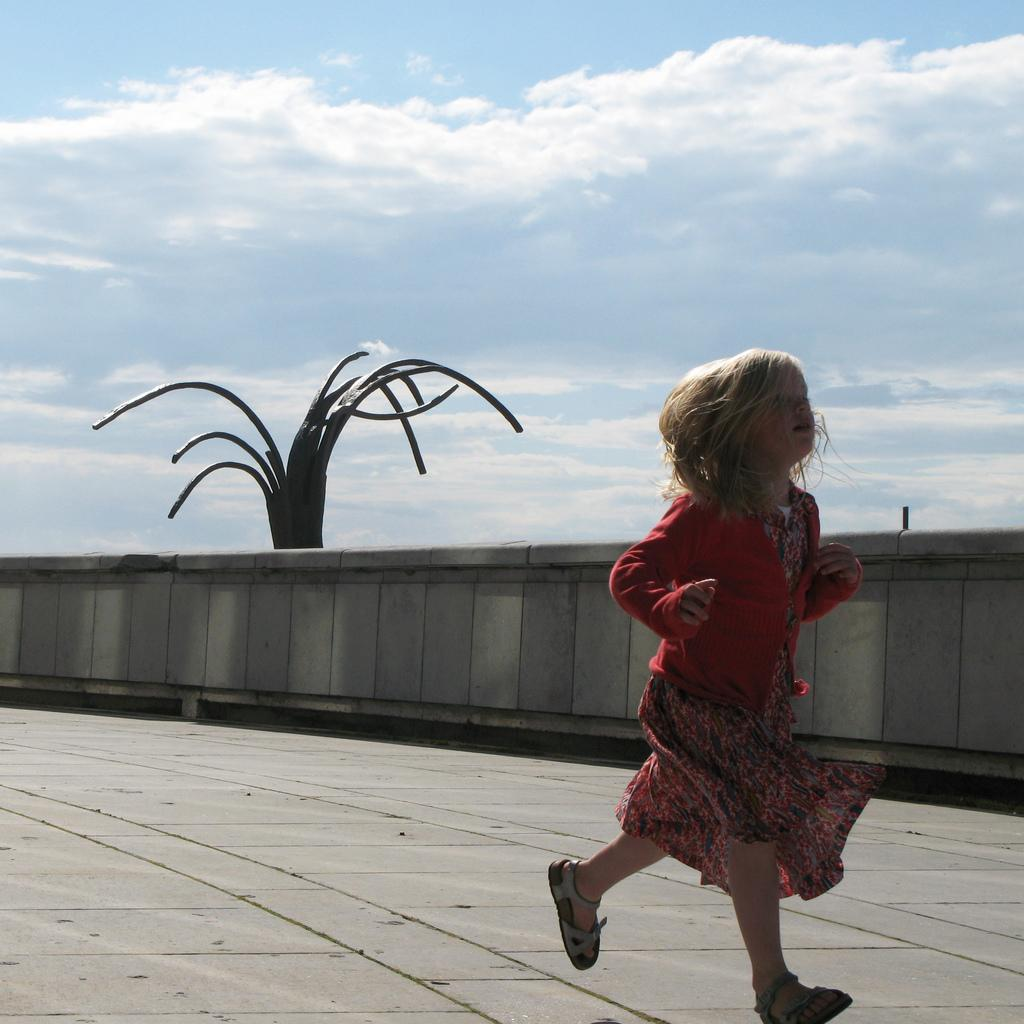Who is the main subject in the image? There is a girl in the image. What is the girl doing in the image? The girl is running. What is the girl wearing in the image? The girl is wearing a red sweater. What can be seen in the background of the image? The sky is visible in the image. How would you describe the weather based on the image? The sky appears to be sunny, suggesting good weather. How many beds are visible in the image? There are no beds present in the image. What type of pain is the girl experiencing in the image? There is no indication of pain in the image; the girl is running and appears to be enjoying herself. 